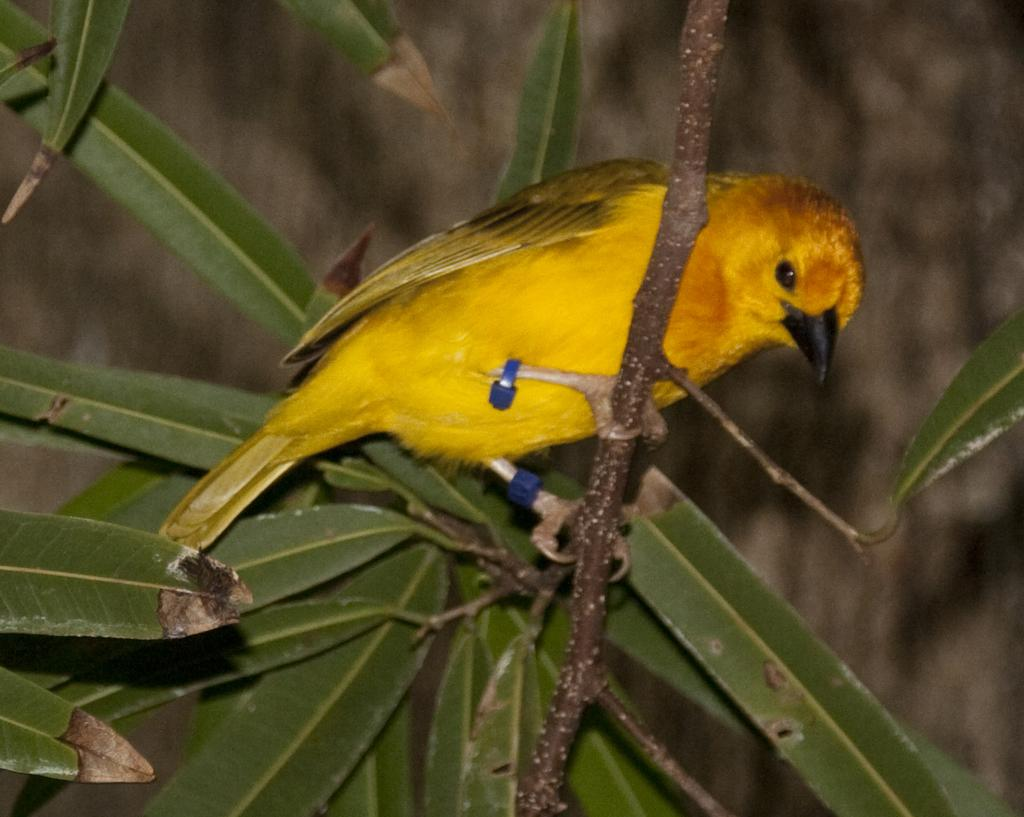What type of animal is in the image? There is a small bird in the image. Where is the bird located in the image? The bird is on a stem with leaves. What color is the bird? The bird is yellow in color. What is the color of the bird's beak? The bird has a black beak. How many sisters are present in the image? There are no sisters present in the image; it features a small yellow bird on a stem with leaves. What type of fruit can be seen in the image? There is no fruit present in the image; it only shows a small yellow bird on a stem with leaves. 